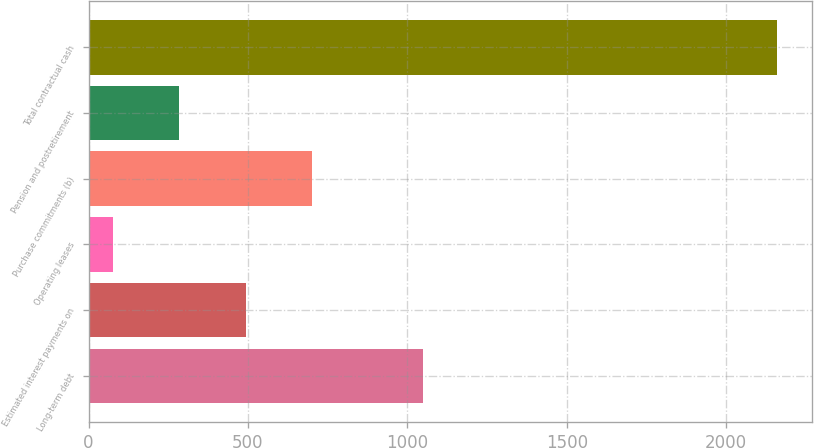Convert chart to OTSL. <chart><loc_0><loc_0><loc_500><loc_500><bar_chart><fcel>Long-term debt<fcel>Estimated interest payments on<fcel>Operating leases<fcel>Purchase commitments (b)<fcel>Pension and postretirement<fcel>Total contractual cash<nl><fcel>1049.3<fcel>493.38<fcel>76.5<fcel>701.82<fcel>284.94<fcel>2160.9<nl></chart> 